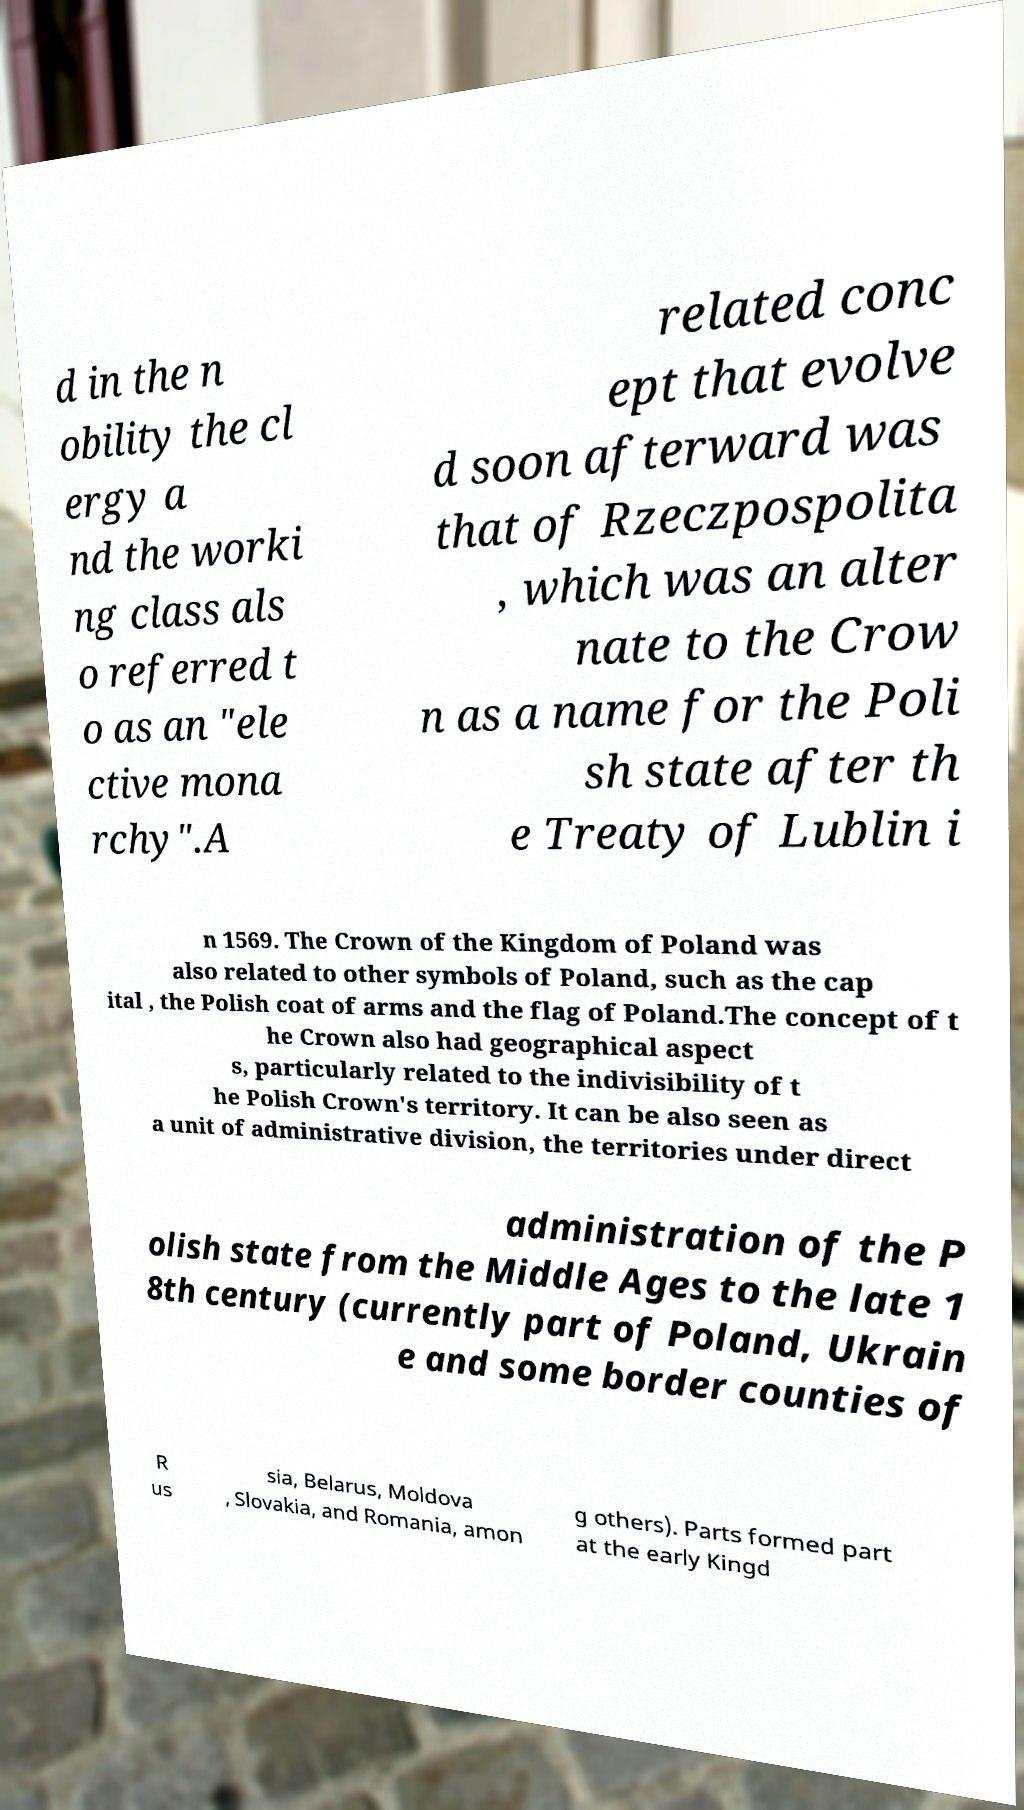Please read and relay the text visible in this image. What does it say? d in the n obility the cl ergy a nd the worki ng class als o referred t o as an "ele ctive mona rchy".A related conc ept that evolve d soon afterward was that of Rzeczpospolita , which was an alter nate to the Crow n as a name for the Poli sh state after th e Treaty of Lublin i n 1569. The Crown of the Kingdom of Poland was also related to other symbols of Poland, such as the cap ital , the Polish coat of arms and the flag of Poland.The concept of t he Crown also had geographical aspect s, particularly related to the indivisibility of t he Polish Crown's territory. It can be also seen as a unit of administrative division, the territories under direct administration of the P olish state from the Middle Ages to the late 1 8th century (currently part of Poland, Ukrain e and some border counties of R us sia, Belarus, Moldova , Slovakia, and Romania, amon g others). Parts formed part at the early Kingd 